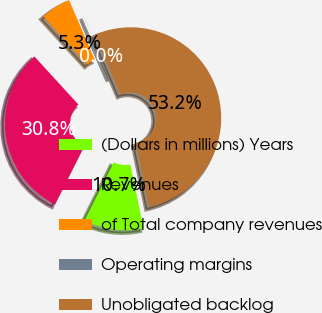Convert chart to OTSL. <chart><loc_0><loc_0><loc_500><loc_500><pie_chart><fcel>(Dollars in millions) Years<fcel>Revenues<fcel>of Total company revenues<fcel>Operating margins<fcel>Unobligated backlog<nl><fcel>10.66%<fcel>30.79%<fcel>5.34%<fcel>0.02%<fcel>53.2%<nl></chart> 